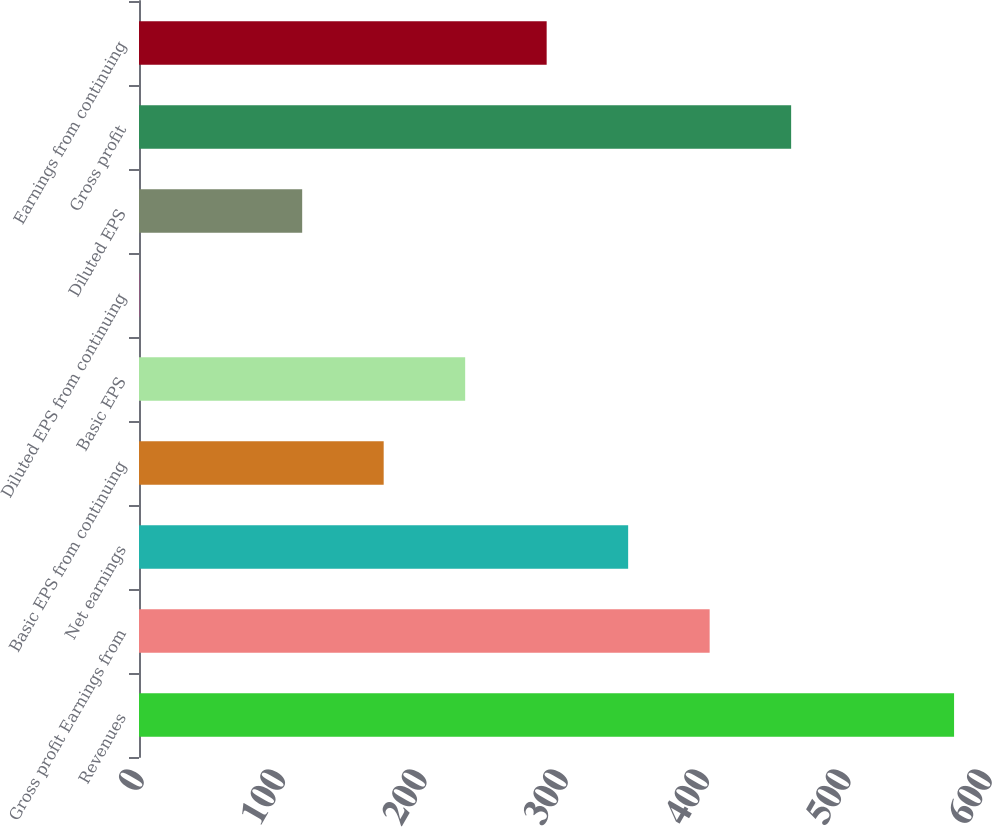<chart> <loc_0><loc_0><loc_500><loc_500><bar_chart><fcel>Revenues<fcel>Gross profit Earnings from<fcel>Net earnings<fcel>Basic EPS from continuing<fcel>Basic EPS<fcel>Diluted EPS from continuing<fcel>Diluted EPS<fcel>Gross profit<fcel>Earnings from continuing<nl><fcel>576.7<fcel>403.76<fcel>346.1<fcel>173.12<fcel>230.78<fcel>0.14<fcel>115.46<fcel>461.42<fcel>288.44<nl></chart> 